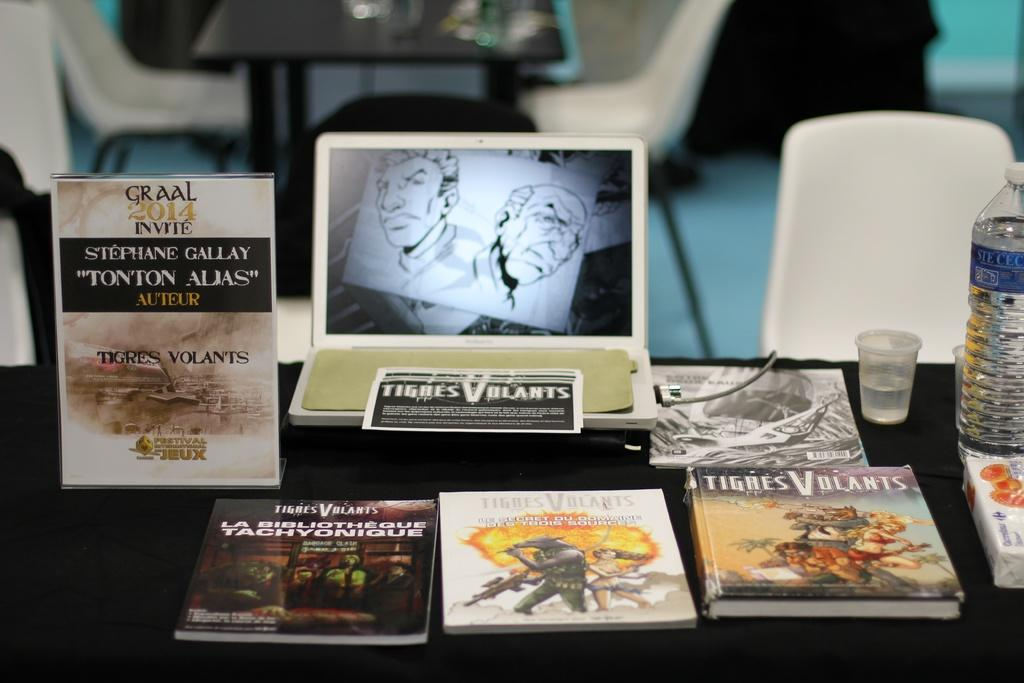What type of furniture is present in the image? There are tables and chairs in the image. What items can be seen on the tables? There are books, a laptop, glasses, and bottles on the tables. How many different types of objects are on the tables? There are five different types of objects on the tables: books, a laptop, glasses, and bottles. What type of mine is visible in the image? There is no mine present in the image. How does the jar contribute to the overall scene in the image? There is no jar present in the image. 